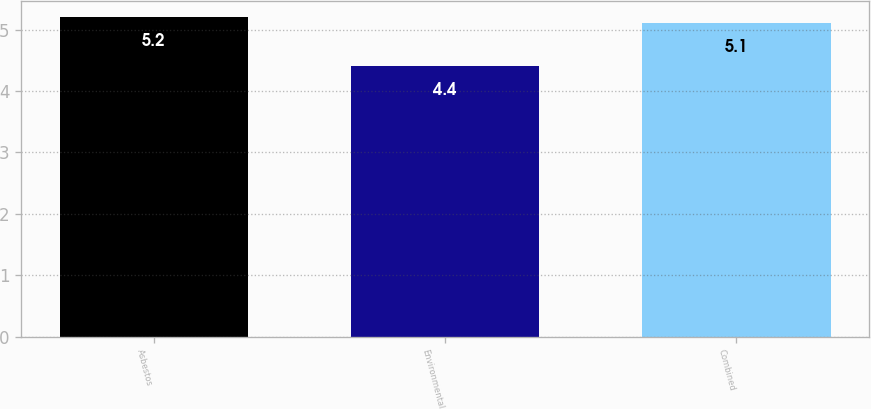Convert chart to OTSL. <chart><loc_0><loc_0><loc_500><loc_500><bar_chart><fcel>Asbestos<fcel>Environmental<fcel>Combined<nl><fcel>5.2<fcel>4.4<fcel>5.1<nl></chart> 